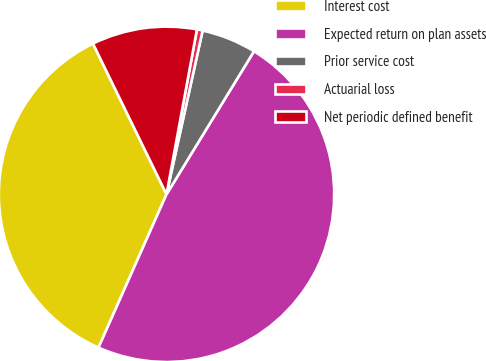Convert chart to OTSL. <chart><loc_0><loc_0><loc_500><loc_500><pie_chart><fcel>Interest cost<fcel>Expected return on plan assets<fcel>Prior service cost<fcel>Actuarial loss<fcel>Net periodic defined benefit<nl><fcel>36.13%<fcel>47.91%<fcel>5.28%<fcel>0.55%<fcel>10.13%<nl></chart> 